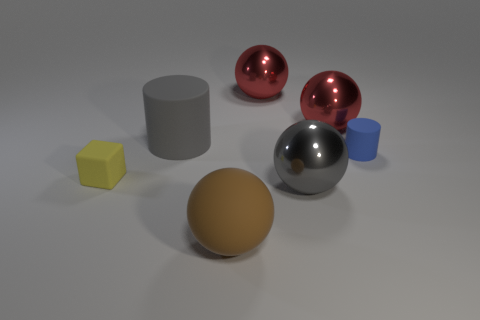How many spheres are big objects or gray shiny things?
Give a very brief answer. 4. There is a rubber thing that is both in front of the blue cylinder and to the right of the yellow cube; what is its size?
Offer a terse response. Large. What number of other objects are the same color as the large matte cylinder?
Give a very brief answer. 1. Is the small yellow object made of the same material as the small thing to the right of the big brown ball?
Give a very brief answer. Yes. What number of objects are either metallic objects that are behind the block or tiny blue rubber cylinders?
Your answer should be compact. 3. What is the shape of the matte thing that is both to the left of the blue cylinder and behind the rubber cube?
Your response must be concise. Cylinder. Is there anything else that is the same size as the blue cylinder?
Keep it short and to the point. Yes. There is a gray thing that is made of the same material as the big brown object; what is its size?
Your response must be concise. Large. What number of objects are spheres that are behind the small matte cylinder or matte cylinders behind the tiny blue matte cylinder?
Make the answer very short. 3. There is a cylinder on the left side of the matte sphere; is it the same size as the big gray metallic ball?
Your answer should be compact. Yes. 